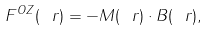<formula> <loc_0><loc_0><loc_500><loc_500>F ^ { O Z } ( \ r ) = - { M } ( \ r ) \cdot { B } ( \ r ) ,</formula> 